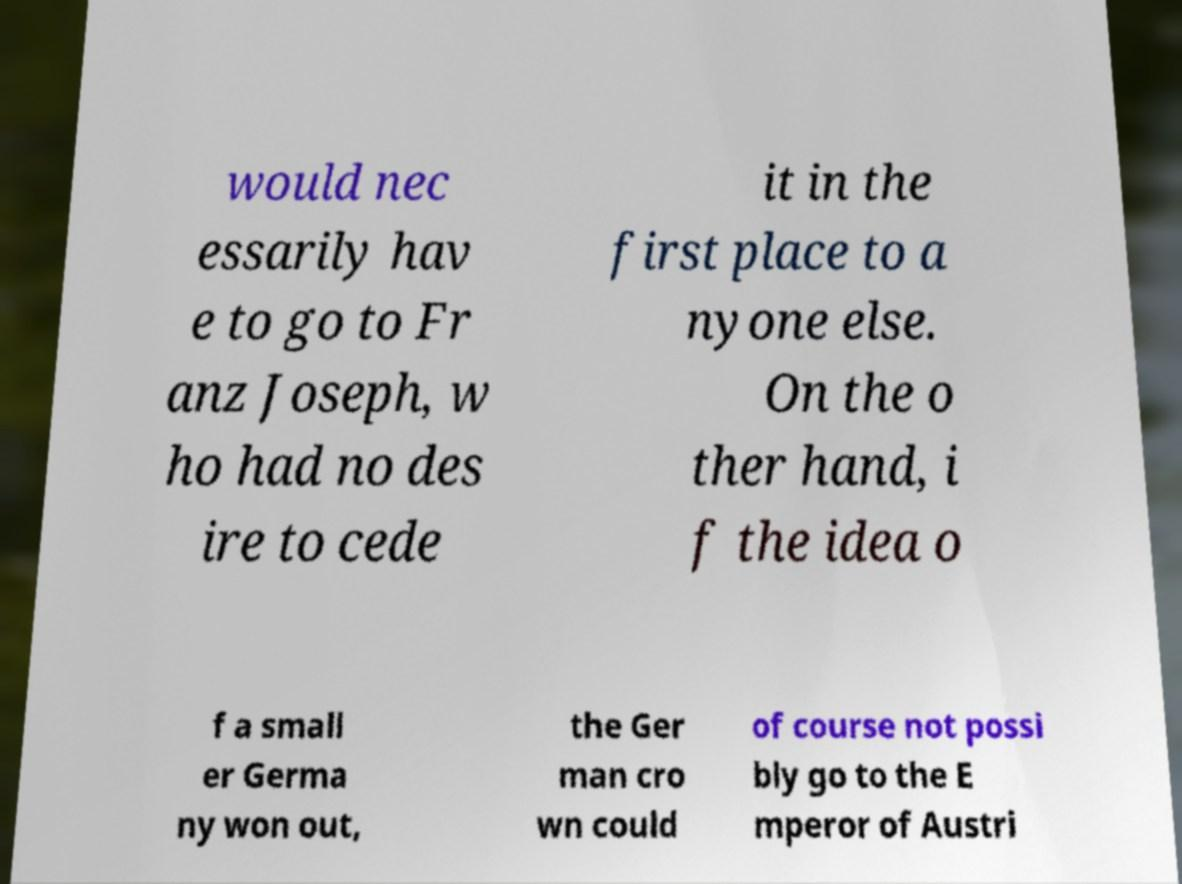What messages or text are displayed in this image? I need them in a readable, typed format. would nec essarily hav e to go to Fr anz Joseph, w ho had no des ire to cede it in the first place to a nyone else. On the o ther hand, i f the idea o f a small er Germa ny won out, the Ger man cro wn could of course not possi bly go to the E mperor of Austri 